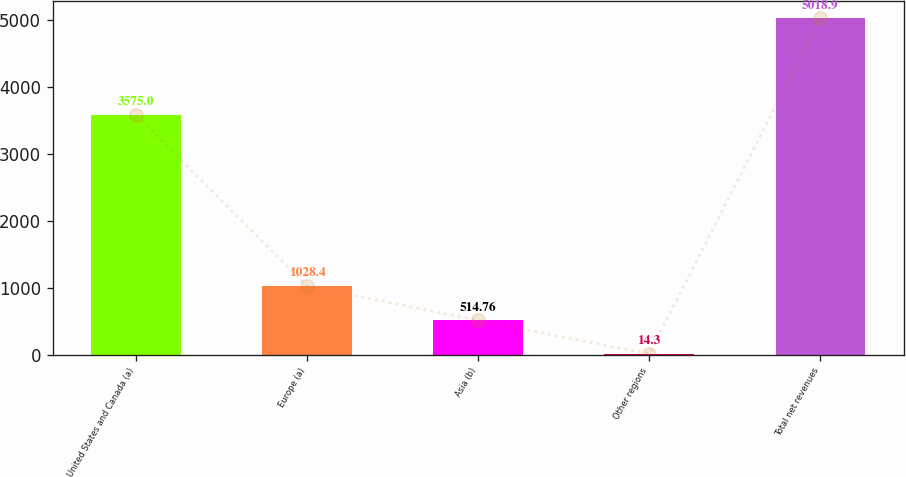Convert chart. <chart><loc_0><loc_0><loc_500><loc_500><bar_chart><fcel>United States and Canada (a)<fcel>Europe (a)<fcel>Asia (b)<fcel>Other regions<fcel>Total net revenues<nl><fcel>3575<fcel>1028.4<fcel>514.76<fcel>14.3<fcel>5018.9<nl></chart> 